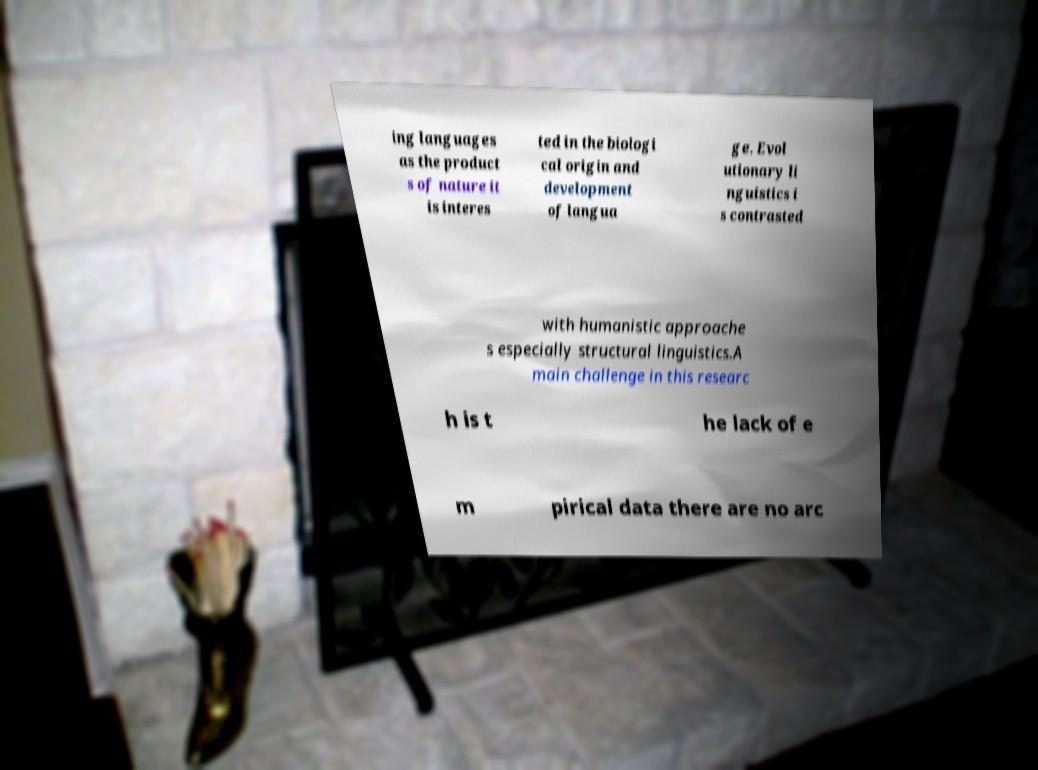What messages or text are displayed in this image? I need them in a readable, typed format. ing languages as the product s of nature it is interes ted in the biologi cal origin and development of langua ge. Evol utionary li nguistics i s contrasted with humanistic approache s especially structural linguistics.A main challenge in this researc h is t he lack of e m pirical data there are no arc 